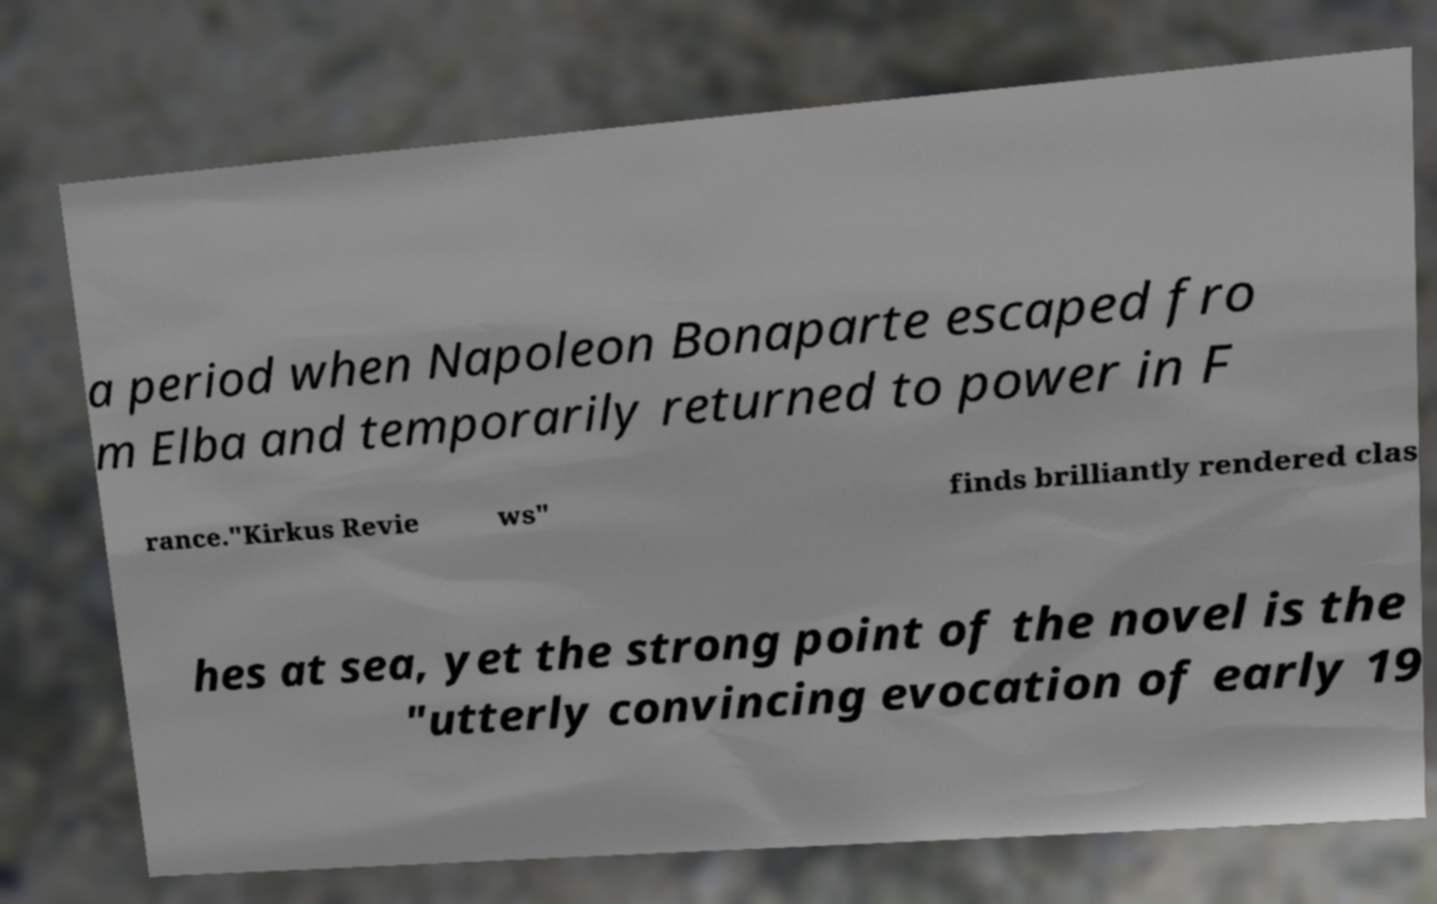Could you extract and type out the text from this image? a period when Napoleon Bonaparte escaped fro m Elba and temporarily returned to power in F rance."Kirkus Revie ws" finds brilliantly rendered clas hes at sea, yet the strong point of the novel is the "utterly convincing evocation of early 19 